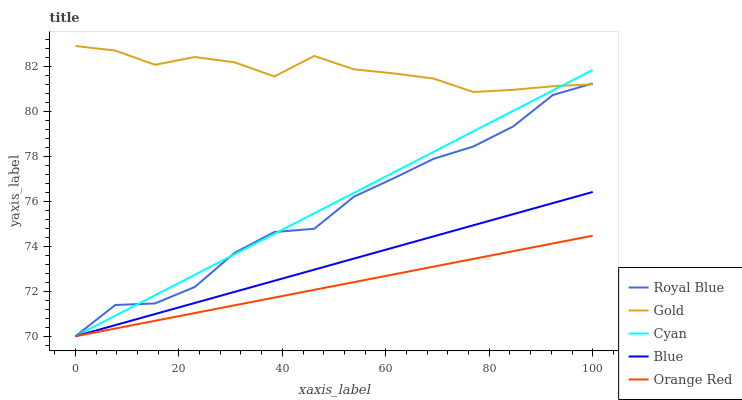Does Orange Red have the minimum area under the curve?
Answer yes or no. Yes. Does Gold have the maximum area under the curve?
Answer yes or no. Yes. Does Royal Blue have the minimum area under the curve?
Answer yes or no. No. Does Royal Blue have the maximum area under the curve?
Answer yes or no. No. Is Orange Red the smoothest?
Answer yes or no. Yes. Is Royal Blue the roughest?
Answer yes or no. Yes. Is Royal Blue the smoothest?
Answer yes or no. No. Is Orange Red the roughest?
Answer yes or no. No. Does Blue have the lowest value?
Answer yes or no. Yes. Does Gold have the lowest value?
Answer yes or no. No. Does Gold have the highest value?
Answer yes or no. Yes. Does Royal Blue have the highest value?
Answer yes or no. No. Is Orange Red less than Gold?
Answer yes or no. Yes. Is Gold greater than Blue?
Answer yes or no. Yes. Does Orange Red intersect Blue?
Answer yes or no. Yes. Is Orange Red less than Blue?
Answer yes or no. No. Is Orange Red greater than Blue?
Answer yes or no. No. Does Orange Red intersect Gold?
Answer yes or no. No. 